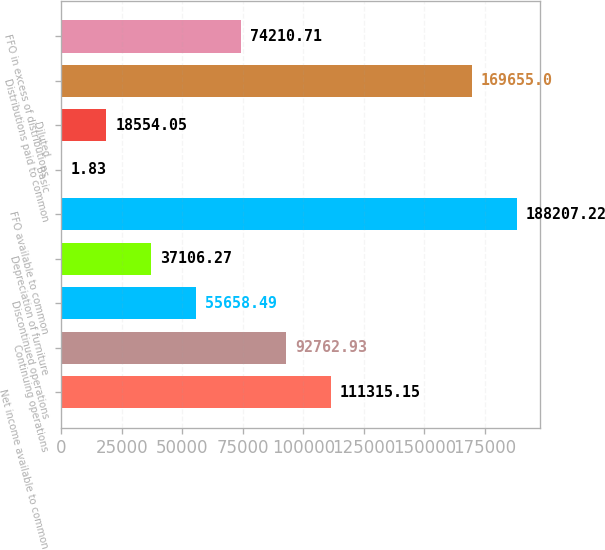<chart> <loc_0><loc_0><loc_500><loc_500><bar_chart><fcel>Net income available to common<fcel>Continuing operations<fcel>Discontinued operations<fcel>Depreciation of furniture<fcel>FFO available to common<fcel>Basic<fcel>Diluted<fcel>Distributions paid to common<fcel>FFO in excess of distributions<nl><fcel>111315<fcel>92762.9<fcel>55658.5<fcel>37106.3<fcel>188207<fcel>1.83<fcel>18554<fcel>169655<fcel>74210.7<nl></chart> 